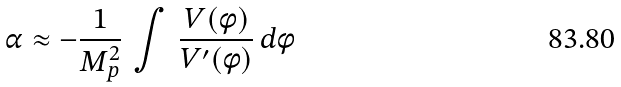Convert formula to latex. <formula><loc_0><loc_0><loc_500><loc_500>\alpha \approx - \frac { 1 } { M _ { p } ^ { 2 } } \, \int \, \frac { V ( \phi ) } { V ^ { \prime } ( \phi ) } \, d \phi</formula> 